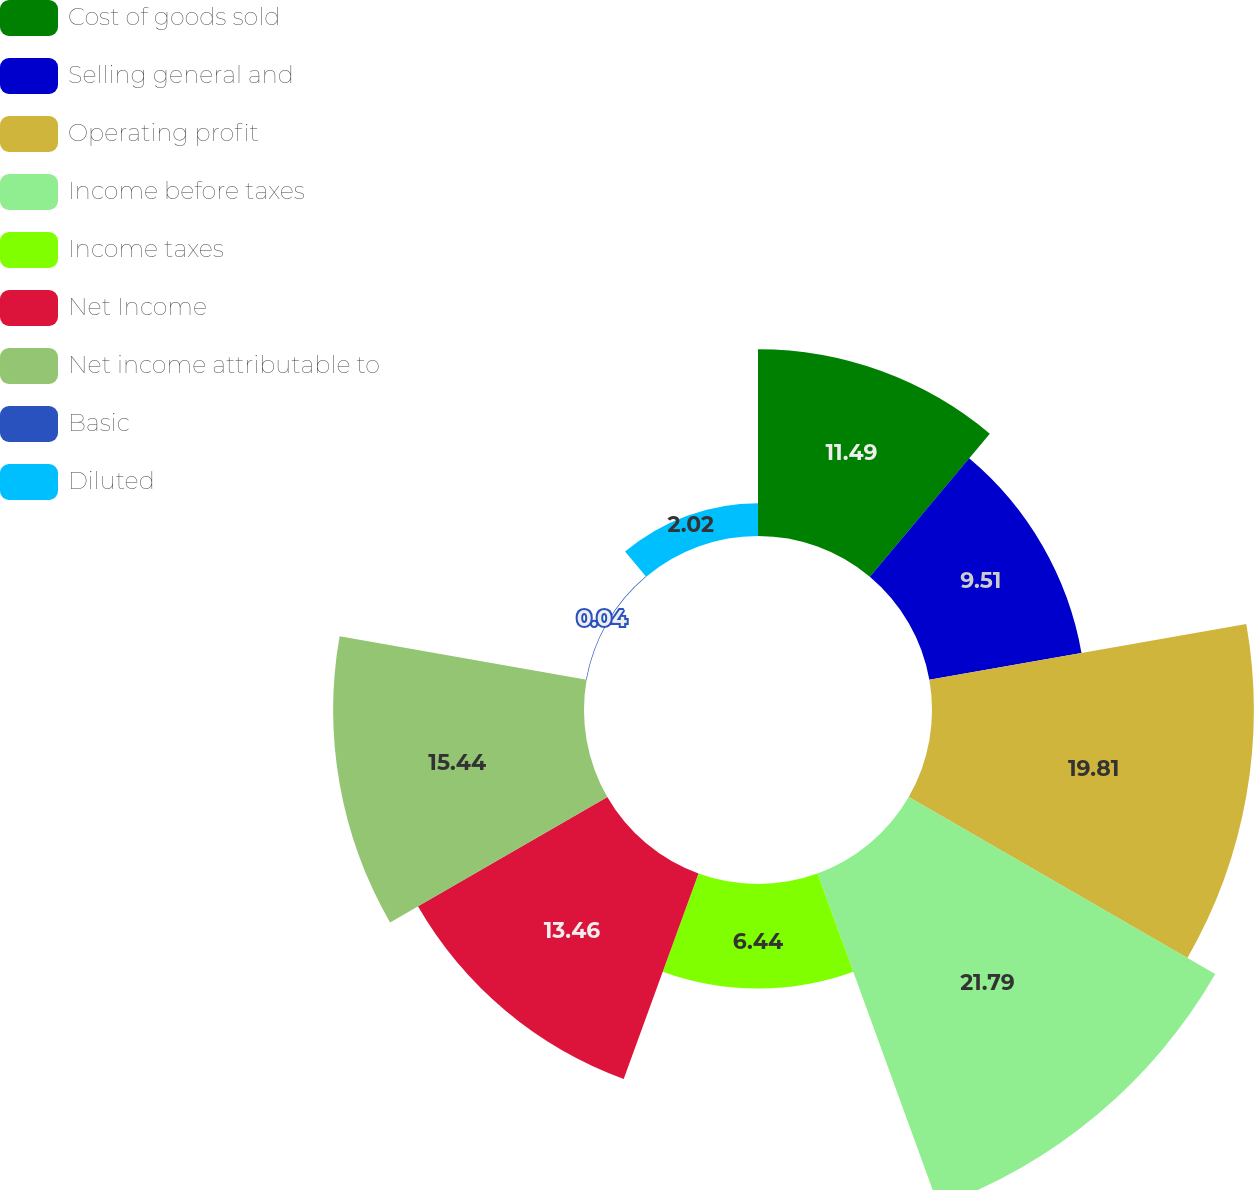Convert chart to OTSL. <chart><loc_0><loc_0><loc_500><loc_500><pie_chart><fcel>Cost of goods sold<fcel>Selling general and<fcel>Operating profit<fcel>Income before taxes<fcel>Income taxes<fcel>Net Income<fcel>Net income attributable to<fcel>Basic<fcel>Diluted<nl><fcel>11.49%<fcel>9.51%<fcel>19.81%<fcel>21.79%<fcel>6.44%<fcel>13.46%<fcel>15.44%<fcel>0.04%<fcel>2.02%<nl></chart> 